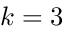Convert formula to latex. <formula><loc_0><loc_0><loc_500><loc_500>k = 3</formula> 